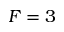Convert formula to latex. <formula><loc_0><loc_0><loc_500><loc_500>F = 3</formula> 